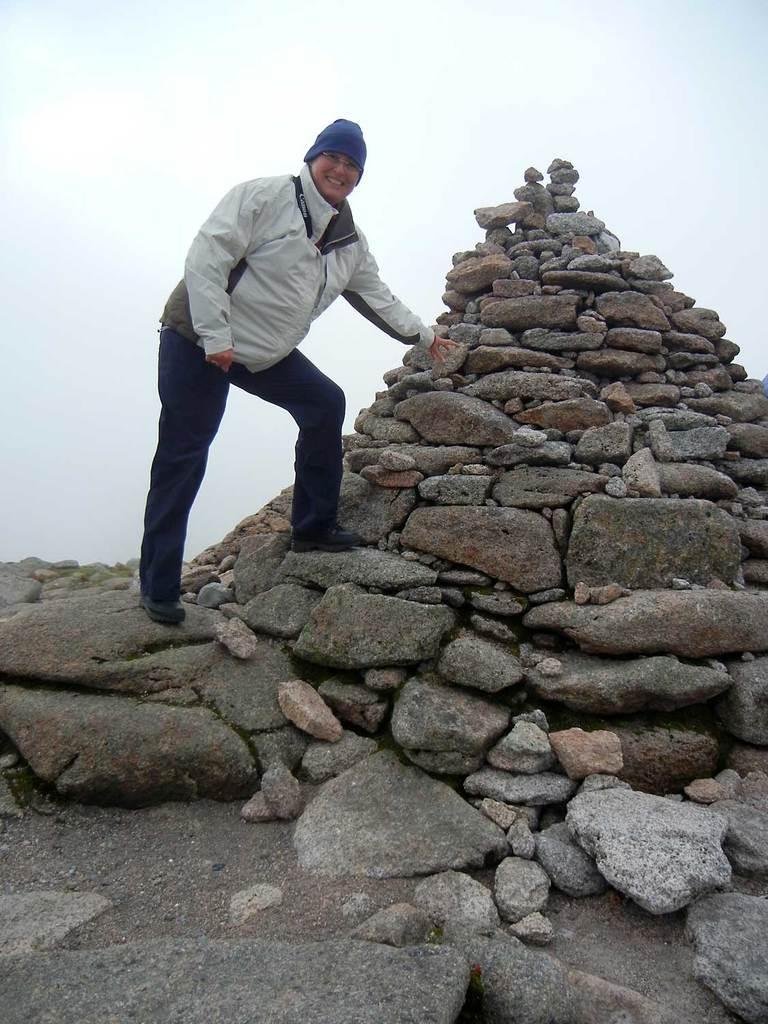Can you describe this image briefly? In this image in the center there are stones and there is a person standing and smiling. 